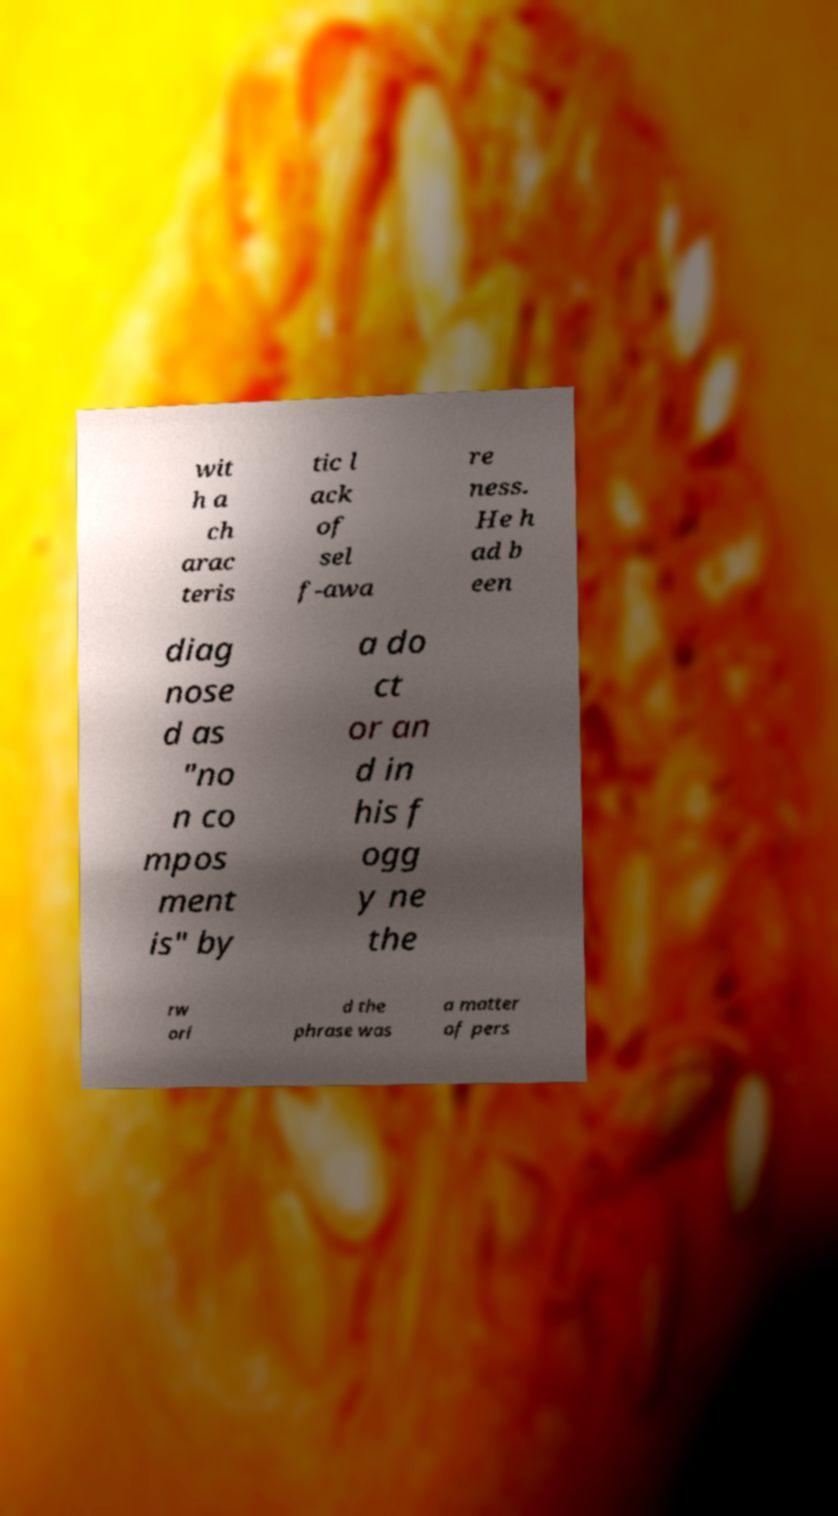Could you assist in decoding the text presented in this image and type it out clearly? wit h a ch arac teris tic l ack of sel f-awa re ness. He h ad b een diag nose d as "no n co mpos ment is" by a do ct or an d in his f ogg y ne the rw orl d the phrase was a matter of pers 